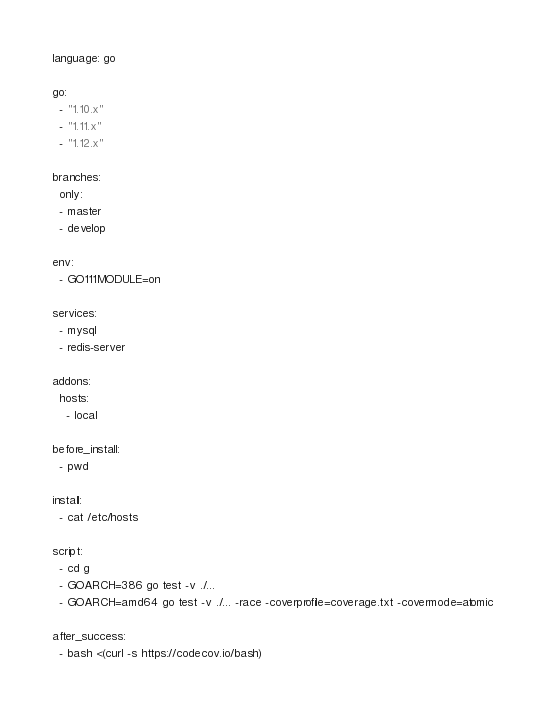Convert code to text. <code><loc_0><loc_0><loc_500><loc_500><_YAML_>language: go

go:
  - "1.10.x"
  - "1.11.x"
  - "1.12.x"

branches:
  only:
  - master
  - develop

env:
  - GO111MODULE=on

services:
  - mysql
  - redis-server

addons:
  hosts:
    - local

before_install:
  - pwd

install:
  - cat /etc/hosts

script:
  - cd g
  - GOARCH=386 go test -v ./...
  - GOARCH=amd64 go test -v ./... -race -coverprofile=coverage.txt -covermode=atomic

after_success:
  - bash <(curl -s https://codecov.io/bash)



</code> 